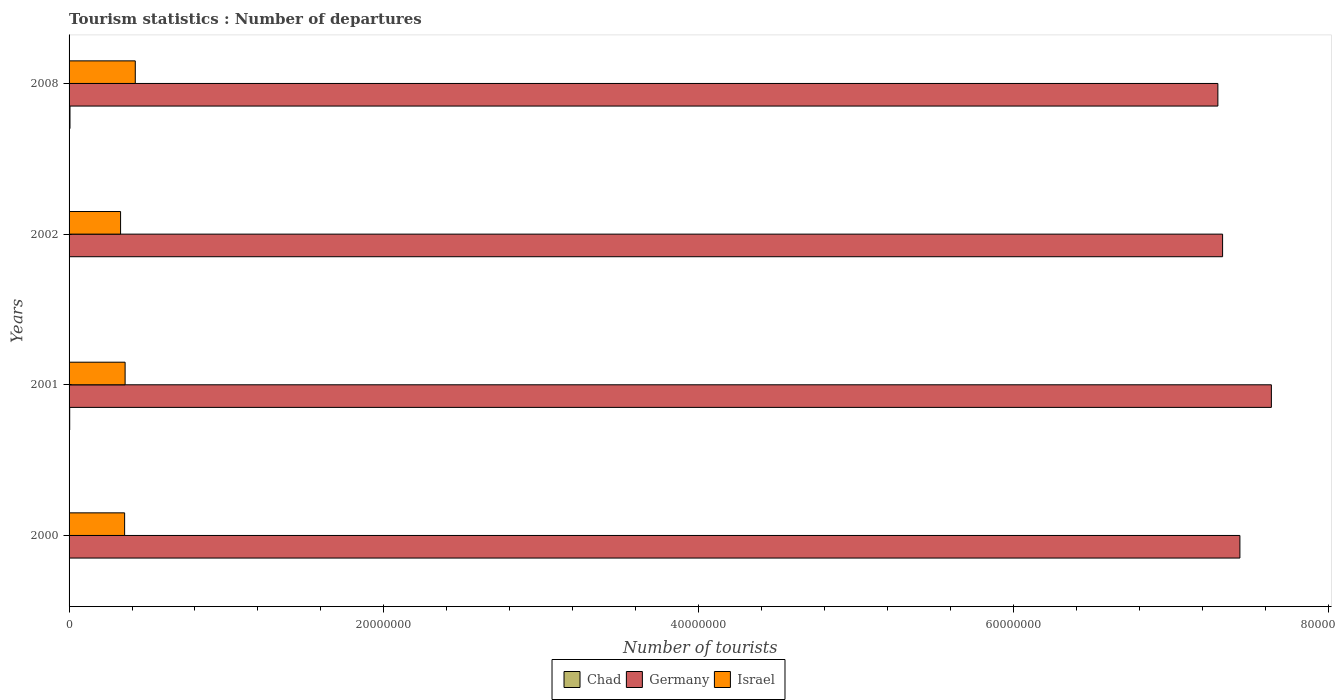How many different coloured bars are there?
Keep it short and to the point. 3. Are the number of bars per tick equal to the number of legend labels?
Your response must be concise. Yes. How many bars are there on the 4th tick from the top?
Provide a succinct answer. 3. How many bars are there on the 4th tick from the bottom?
Keep it short and to the point. 3. What is the label of the 1st group of bars from the top?
Offer a very short reply. 2008. In how many cases, is the number of bars for a given year not equal to the number of legend labels?
Make the answer very short. 0. What is the number of tourist departures in Israel in 2002?
Provide a short and direct response. 3.27e+06. Across all years, what is the maximum number of tourist departures in Chad?
Ensure brevity in your answer.  5.80e+04. Across all years, what is the minimum number of tourist departures in Chad?
Ensure brevity in your answer.  2.30e+04. In which year was the number of tourist departures in Israel maximum?
Offer a terse response. 2008. In which year was the number of tourist departures in Chad minimum?
Keep it short and to the point. 2002. What is the total number of tourist departures in Germany in the graph?
Offer a very short reply. 2.97e+08. What is the difference between the number of tourist departures in Israel in 2000 and that in 2001?
Offer a very short reply. -3.10e+04. What is the difference between the number of tourist departures in Israel in 2000 and the number of tourist departures in Germany in 2008?
Provide a succinct answer. -6.95e+07. What is the average number of tourist departures in Germany per year?
Your answer should be very brief. 7.43e+07. In the year 2008, what is the difference between the number of tourist departures in Germany and number of tourist departures in Israel?
Your response must be concise. 6.88e+07. In how many years, is the number of tourist departures in Israel greater than 76000000 ?
Make the answer very short. 0. What is the ratio of the number of tourist departures in Israel in 2002 to that in 2008?
Your response must be concise. 0.78. Is the number of tourist departures in Israel in 2001 less than that in 2002?
Offer a terse response. No. Is the difference between the number of tourist departures in Germany in 2000 and 2002 greater than the difference between the number of tourist departures in Israel in 2000 and 2002?
Give a very brief answer. Yes. What is the difference between the highest and the second highest number of tourist departures in Chad?
Your answer should be compact. 1.80e+04. What is the difference between the highest and the lowest number of tourist departures in Germany?
Ensure brevity in your answer.  3.40e+06. What does the 3rd bar from the top in 2000 represents?
Provide a short and direct response. Chad. What does the 3rd bar from the bottom in 2008 represents?
Keep it short and to the point. Israel. How many bars are there?
Your answer should be compact. 12. What is the difference between two consecutive major ticks on the X-axis?
Ensure brevity in your answer.  2.00e+07. Does the graph contain any zero values?
Your answer should be compact. No. Does the graph contain grids?
Offer a very short reply. No. How many legend labels are there?
Provide a succinct answer. 3. How are the legend labels stacked?
Keep it short and to the point. Horizontal. What is the title of the graph?
Offer a terse response. Tourism statistics : Number of departures. Does "Uzbekistan" appear as one of the legend labels in the graph?
Your response must be concise. No. What is the label or title of the X-axis?
Your answer should be very brief. Number of tourists. What is the Number of tourists in Chad in 2000?
Make the answer very short. 2.70e+04. What is the Number of tourists in Germany in 2000?
Keep it short and to the point. 7.44e+07. What is the Number of tourists in Israel in 2000?
Your answer should be compact. 3.53e+06. What is the Number of tourists of Germany in 2001?
Ensure brevity in your answer.  7.64e+07. What is the Number of tourists in Israel in 2001?
Ensure brevity in your answer.  3.56e+06. What is the Number of tourists of Chad in 2002?
Give a very brief answer. 2.30e+04. What is the Number of tourists of Germany in 2002?
Keep it short and to the point. 7.33e+07. What is the Number of tourists of Israel in 2002?
Ensure brevity in your answer.  3.27e+06. What is the Number of tourists in Chad in 2008?
Your answer should be compact. 5.80e+04. What is the Number of tourists in Germany in 2008?
Provide a succinct answer. 7.30e+07. What is the Number of tourists of Israel in 2008?
Your answer should be very brief. 4.21e+06. Across all years, what is the maximum Number of tourists in Chad?
Offer a very short reply. 5.80e+04. Across all years, what is the maximum Number of tourists in Germany?
Provide a short and direct response. 7.64e+07. Across all years, what is the maximum Number of tourists in Israel?
Your answer should be compact. 4.21e+06. Across all years, what is the minimum Number of tourists of Chad?
Provide a succinct answer. 2.30e+04. Across all years, what is the minimum Number of tourists in Germany?
Ensure brevity in your answer.  7.30e+07. Across all years, what is the minimum Number of tourists of Israel?
Your response must be concise. 3.27e+06. What is the total Number of tourists of Chad in the graph?
Give a very brief answer. 1.48e+05. What is the total Number of tourists of Germany in the graph?
Make the answer very short. 2.97e+08. What is the total Number of tourists of Israel in the graph?
Give a very brief answer. 1.46e+07. What is the difference between the Number of tourists in Chad in 2000 and that in 2001?
Your answer should be compact. -1.30e+04. What is the difference between the Number of tourists of Germany in 2000 and that in 2001?
Offer a terse response. -2.00e+06. What is the difference between the Number of tourists in Israel in 2000 and that in 2001?
Your answer should be very brief. -3.10e+04. What is the difference between the Number of tourists of Chad in 2000 and that in 2002?
Your answer should be very brief. 4000. What is the difference between the Number of tourists of Germany in 2000 and that in 2002?
Make the answer very short. 1.10e+06. What is the difference between the Number of tourists in Israel in 2000 and that in 2002?
Provide a succinct answer. 2.57e+05. What is the difference between the Number of tourists in Chad in 2000 and that in 2008?
Make the answer very short. -3.10e+04. What is the difference between the Number of tourists in Germany in 2000 and that in 2008?
Provide a short and direct response. 1.40e+06. What is the difference between the Number of tourists of Israel in 2000 and that in 2008?
Keep it short and to the point. -6.77e+05. What is the difference between the Number of tourists in Chad in 2001 and that in 2002?
Your answer should be compact. 1.70e+04. What is the difference between the Number of tourists of Germany in 2001 and that in 2002?
Give a very brief answer. 3.10e+06. What is the difference between the Number of tourists of Israel in 2001 and that in 2002?
Keep it short and to the point. 2.88e+05. What is the difference between the Number of tourists in Chad in 2001 and that in 2008?
Offer a terse response. -1.80e+04. What is the difference between the Number of tourists of Germany in 2001 and that in 2008?
Provide a short and direct response. 3.40e+06. What is the difference between the Number of tourists of Israel in 2001 and that in 2008?
Make the answer very short. -6.46e+05. What is the difference between the Number of tourists in Chad in 2002 and that in 2008?
Give a very brief answer. -3.50e+04. What is the difference between the Number of tourists of Germany in 2002 and that in 2008?
Your answer should be compact. 3.00e+05. What is the difference between the Number of tourists of Israel in 2002 and that in 2008?
Provide a succinct answer. -9.34e+05. What is the difference between the Number of tourists of Chad in 2000 and the Number of tourists of Germany in 2001?
Ensure brevity in your answer.  -7.64e+07. What is the difference between the Number of tourists of Chad in 2000 and the Number of tourists of Israel in 2001?
Make the answer very short. -3.53e+06. What is the difference between the Number of tourists of Germany in 2000 and the Number of tourists of Israel in 2001?
Keep it short and to the point. 7.08e+07. What is the difference between the Number of tourists in Chad in 2000 and the Number of tourists in Germany in 2002?
Ensure brevity in your answer.  -7.33e+07. What is the difference between the Number of tourists in Chad in 2000 and the Number of tourists in Israel in 2002?
Keep it short and to the point. -3.25e+06. What is the difference between the Number of tourists of Germany in 2000 and the Number of tourists of Israel in 2002?
Your answer should be very brief. 7.11e+07. What is the difference between the Number of tourists of Chad in 2000 and the Number of tourists of Germany in 2008?
Provide a short and direct response. -7.30e+07. What is the difference between the Number of tourists in Chad in 2000 and the Number of tourists in Israel in 2008?
Your answer should be compact. -4.18e+06. What is the difference between the Number of tourists of Germany in 2000 and the Number of tourists of Israel in 2008?
Offer a very short reply. 7.02e+07. What is the difference between the Number of tourists in Chad in 2001 and the Number of tourists in Germany in 2002?
Keep it short and to the point. -7.33e+07. What is the difference between the Number of tourists of Chad in 2001 and the Number of tourists of Israel in 2002?
Give a very brief answer. -3.23e+06. What is the difference between the Number of tourists of Germany in 2001 and the Number of tourists of Israel in 2002?
Give a very brief answer. 7.31e+07. What is the difference between the Number of tourists of Chad in 2001 and the Number of tourists of Germany in 2008?
Your answer should be very brief. -7.30e+07. What is the difference between the Number of tourists of Chad in 2001 and the Number of tourists of Israel in 2008?
Provide a succinct answer. -4.17e+06. What is the difference between the Number of tourists in Germany in 2001 and the Number of tourists in Israel in 2008?
Provide a succinct answer. 7.22e+07. What is the difference between the Number of tourists of Chad in 2002 and the Number of tourists of Germany in 2008?
Make the answer very short. -7.30e+07. What is the difference between the Number of tourists in Chad in 2002 and the Number of tourists in Israel in 2008?
Your answer should be compact. -4.18e+06. What is the difference between the Number of tourists of Germany in 2002 and the Number of tourists of Israel in 2008?
Keep it short and to the point. 6.91e+07. What is the average Number of tourists of Chad per year?
Offer a terse response. 3.70e+04. What is the average Number of tourists in Germany per year?
Ensure brevity in your answer.  7.43e+07. What is the average Number of tourists of Israel per year?
Your answer should be very brief. 3.64e+06. In the year 2000, what is the difference between the Number of tourists of Chad and Number of tourists of Germany?
Make the answer very short. -7.44e+07. In the year 2000, what is the difference between the Number of tourists of Chad and Number of tourists of Israel?
Your response must be concise. -3.50e+06. In the year 2000, what is the difference between the Number of tourists of Germany and Number of tourists of Israel?
Keep it short and to the point. 7.09e+07. In the year 2001, what is the difference between the Number of tourists of Chad and Number of tourists of Germany?
Your answer should be compact. -7.64e+07. In the year 2001, what is the difference between the Number of tourists of Chad and Number of tourists of Israel?
Provide a succinct answer. -3.52e+06. In the year 2001, what is the difference between the Number of tourists in Germany and Number of tourists in Israel?
Your answer should be very brief. 7.28e+07. In the year 2002, what is the difference between the Number of tourists in Chad and Number of tourists in Germany?
Keep it short and to the point. -7.33e+07. In the year 2002, what is the difference between the Number of tourists in Chad and Number of tourists in Israel?
Keep it short and to the point. -3.25e+06. In the year 2002, what is the difference between the Number of tourists of Germany and Number of tourists of Israel?
Ensure brevity in your answer.  7.00e+07. In the year 2008, what is the difference between the Number of tourists of Chad and Number of tourists of Germany?
Ensure brevity in your answer.  -7.29e+07. In the year 2008, what is the difference between the Number of tourists of Chad and Number of tourists of Israel?
Ensure brevity in your answer.  -4.15e+06. In the year 2008, what is the difference between the Number of tourists in Germany and Number of tourists in Israel?
Give a very brief answer. 6.88e+07. What is the ratio of the Number of tourists of Chad in 2000 to that in 2001?
Make the answer very short. 0.68. What is the ratio of the Number of tourists of Germany in 2000 to that in 2001?
Make the answer very short. 0.97. What is the ratio of the Number of tourists of Israel in 2000 to that in 2001?
Make the answer very short. 0.99. What is the ratio of the Number of tourists of Chad in 2000 to that in 2002?
Ensure brevity in your answer.  1.17. What is the ratio of the Number of tourists of Germany in 2000 to that in 2002?
Give a very brief answer. 1.01. What is the ratio of the Number of tourists of Israel in 2000 to that in 2002?
Your answer should be compact. 1.08. What is the ratio of the Number of tourists of Chad in 2000 to that in 2008?
Offer a very short reply. 0.47. What is the ratio of the Number of tourists of Germany in 2000 to that in 2008?
Your response must be concise. 1.02. What is the ratio of the Number of tourists of Israel in 2000 to that in 2008?
Provide a succinct answer. 0.84. What is the ratio of the Number of tourists in Chad in 2001 to that in 2002?
Ensure brevity in your answer.  1.74. What is the ratio of the Number of tourists in Germany in 2001 to that in 2002?
Provide a short and direct response. 1.04. What is the ratio of the Number of tourists in Israel in 2001 to that in 2002?
Keep it short and to the point. 1.09. What is the ratio of the Number of tourists of Chad in 2001 to that in 2008?
Offer a terse response. 0.69. What is the ratio of the Number of tourists in Germany in 2001 to that in 2008?
Provide a succinct answer. 1.05. What is the ratio of the Number of tourists in Israel in 2001 to that in 2008?
Make the answer very short. 0.85. What is the ratio of the Number of tourists of Chad in 2002 to that in 2008?
Your answer should be compact. 0.4. What is the ratio of the Number of tourists in Israel in 2002 to that in 2008?
Ensure brevity in your answer.  0.78. What is the difference between the highest and the second highest Number of tourists in Chad?
Your answer should be compact. 1.80e+04. What is the difference between the highest and the second highest Number of tourists in Israel?
Your answer should be very brief. 6.46e+05. What is the difference between the highest and the lowest Number of tourists of Chad?
Give a very brief answer. 3.50e+04. What is the difference between the highest and the lowest Number of tourists in Germany?
Ensure brevity in your answer.  3.40e+06. What is the difference between the highest and the lowest Number of tourists in Israel?
Your response must be concise. 9.34e+05. 